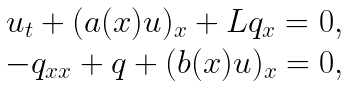Convert formula to latex. <formula><loc_0><loc_0><loc_500><loc_500>\begin{matrix} u _ { t } + ( a ( x ) u ) _ { x } + L q _ { x } = 0 , \\ - q _ { x x } + q + ( b ( x ) u ) _ { x } = 0 , \end{matrix}</formula> 